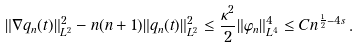<formula> <loc_0><loc_0><loc_500><loc_500>\| \nabla q _ { n } ( t ) \| _ { L ^ { 2 } } ^ { 2 } - n ( n + 1 ) \| q _ { n } ( t ) \| _ { L ^ { 2 } } ^ { 2 } \leq \frac { \kappa ^ { 2 } } { 2 } \| \varphi _ { n } \| _ { L ^ { 4 } } ^ { 4 } \leq C n ^ { \frac { 1 } { 2 } - 4 s } \, .</formula> 